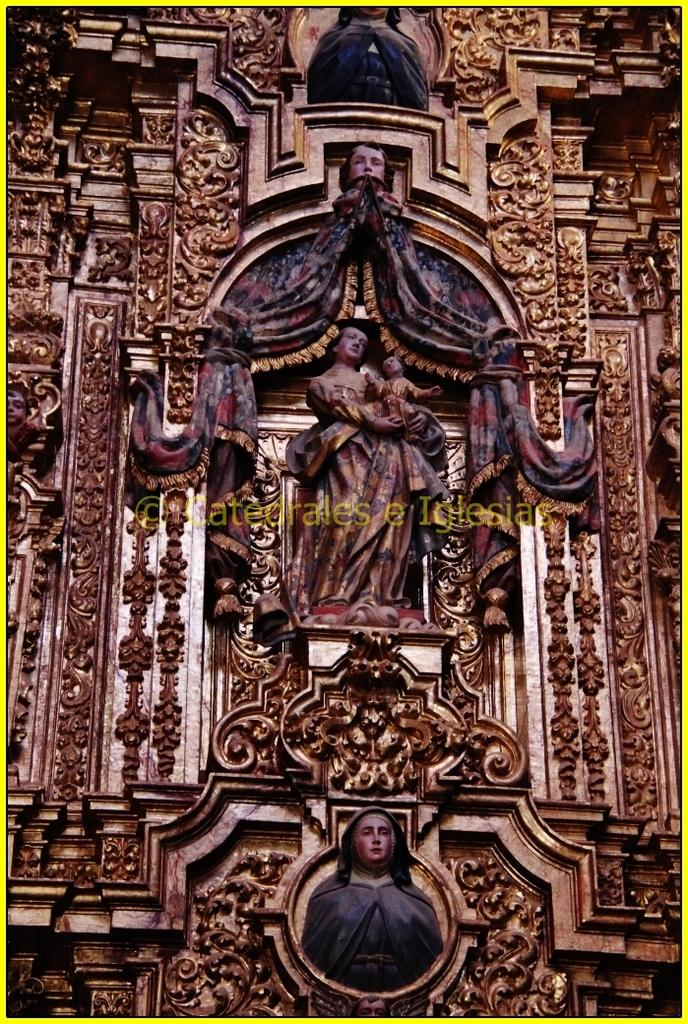What type of objects are featured in the image? There are carved wooden sculptures in the image. Can you describe any additional features of the image? Yes, there is a watermark on the image. What news is being reported by the pancake in the image? There is no pancake present in the image, and therefore no news can be reported by it. 